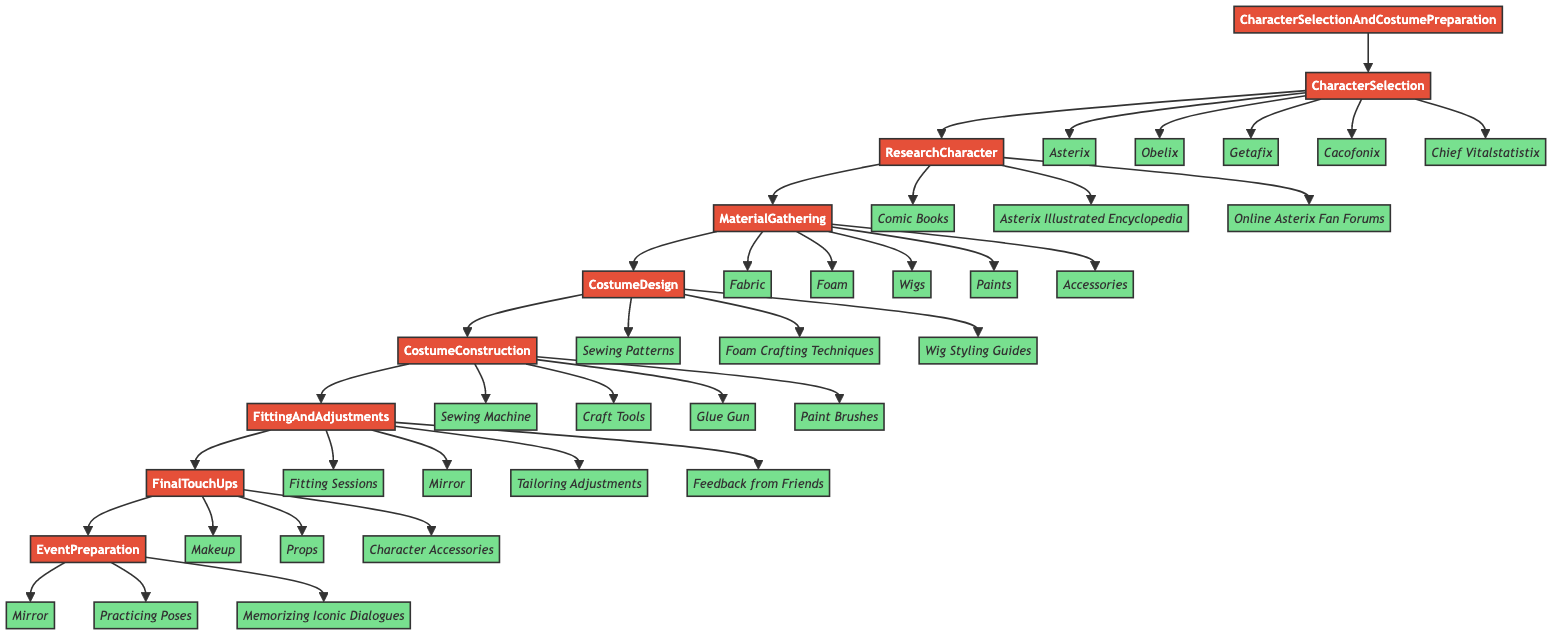What is the first step in the flowchart? The first step in the flowchart is identified as "CharacterSelection," which is the starting point for the process.
Answer: CharacterSelection How many characters can be selected in the CharacterSelection step? The CharacterSelection step shows five options for characters: Asterix, Obelix, Getafix, Cacofonix, and Chief Vitalstatistix, making a total of five.
Answer: 5 Which step follows MaterialGathering? The step immediately following MaterialGathering is CostumeDesign, as shown by the directed flow in the diagram.
Answer: CostumeDesign What entities are involved in the CostumeConstruction step? The CostumeConstruction step includes four entities: Sewing Machine, Craft Tools, Glue Gun, and Paint Brushes.
Answer: Sewing Machine, Craft Tools, Glue Gun, Paint Brushes What is the final step in the process? The final step represented in the flowchart is EventPreparation, which wraps up the sequence of actions needed for the Asterix cosplay event.
Answer: EventPreparation Which step requires feedback from friends? The step that incorporates feedback from friends is FittingAndAdjustments, indicating that social input is valued for costume refinement.
Answer: FittingAndAdjustments What is the common goal of the steps leading up to EventPreparation? The common goal across the preceding steps is to ensure the costume is well-prepared, accurately designed, and ready for the cosplay event, collectively aimed at successful participation.
Answer: Prepare for the event How many types of materials are gathered in the MaterialGathering step? Five types of materials are specified in the MaterialGathering step: Fabric, Foam, Wigs, Paints, and Accessories, leading to the total count.
Answer: 5 Which step involves rehearsing character poses? The rehearsing of character poses is highlighted in the EventPreparation step, emphasizing preparation for performance at the event.
Answer: EventPreparation 